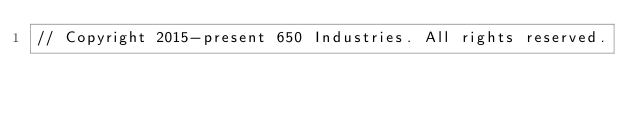Convert code to text. <code><loc_0><loc_0><loc_500><loc_500><_Java_>// Copyright 2015-present 650 Industries. All rights reserved.
</code> 